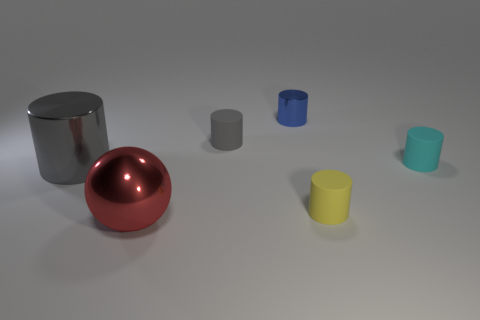Add 2 tiny cyan spheres. How many objects exist? 8 Subtract all gray shiny cylinders. How many cylinders are left? 4 Subtract all yellow cylinders. How many cylinders are left? 4 Subtract all red balls. How many green cylinders are left? 0 Subtract all matte cylinders. Subtract all large red balls. How many objects are left? 2 Add 2 yellow cylinders. How many yellow cylinders are left? 3 Add 3 tiny yellow matte objects. How many tiny yellow matte objects exist? 4 Subtract 0 gray cubes. How many objects are left? 6 Subtract all balls. How many objects are left? 5 Subtract all green balls. Subtract all purple cylinders. How many balls are left? 1 